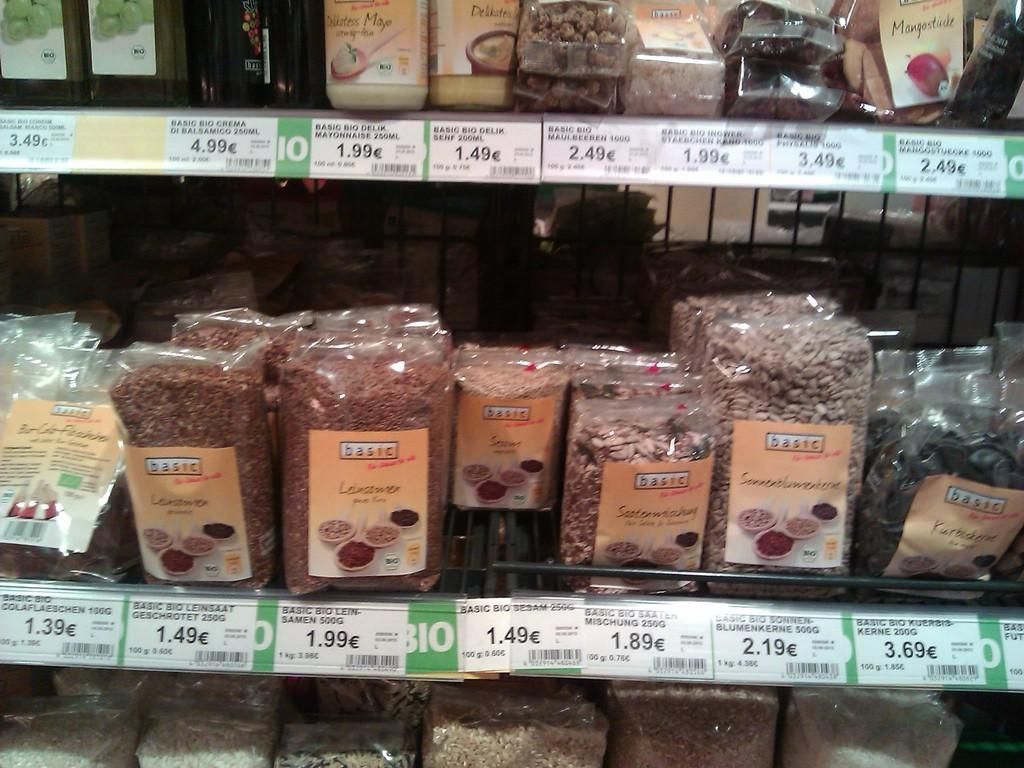<image>
Relay a brief, clear account of the picture shown. An advert for what looks like seeds, many of which are in packages reading Basic. 